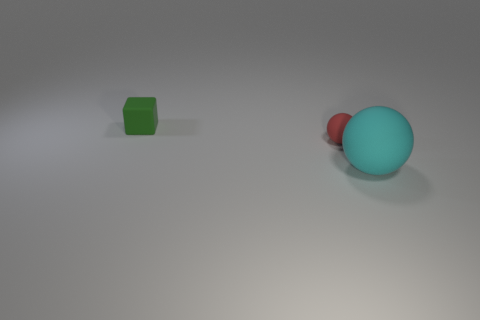What is the size of the red object that is the same material as the green thing?
Provide a succinct answer. Small. Is the number of tiny purple objects greater than the number of red spheres?
Provide a short and direct response. No. There is a tiny object on the right side of the small green rubber object; what color is it?
Your answer should be compact. Red. There is a thing that is in front of the tiny green object and behind the big cyan rubber thing; what is its size?
Your answer should be very brief. Small. What number of matte objects are the same size as the green cube?
Your answer should be compact. 1. Does the big cyan thing have the same shape as the red matte object?
Keep it short and to the point. Yes. What number of tiny objects are behind the red ball?
Your answer should be very brief. 1. There is a small object that is right of the small object that is behind the red ball; what is its shape?
Your answer should be very brief. Sphere. What shape is the small green thing that is the same material as the large thing?
Offer a terse response. Cube. There is a object that is behind the tiny red sphere; does it have the same size as the sphere that is behind the cyan sphere?
Make the answer very short. Yes. 